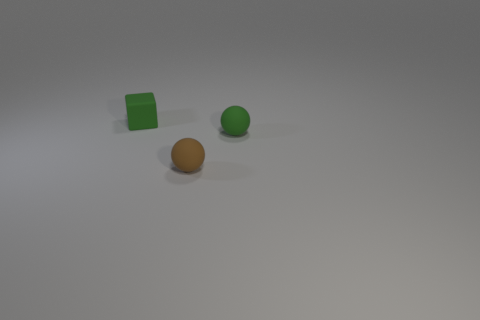What number of brown objects are matte things or big objects? There is one large, matte brown object in the image, which appears to be a sphere. No other brown objects fit the criteria for being either matte or large. 